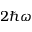Convert formula to latex. <formula><loc_0><loc_0><loc_500><loc_500>2 \hbar { \omega }</formula> 